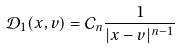<formula> <loc_0><loc_0><loc_500><loc_500>\mathcal { D } _ { 1 } ( x , v ) = \mathcal { C } _ { n } \frac { 1 } { | x - v | ^ { n - 1 } }</formula> 